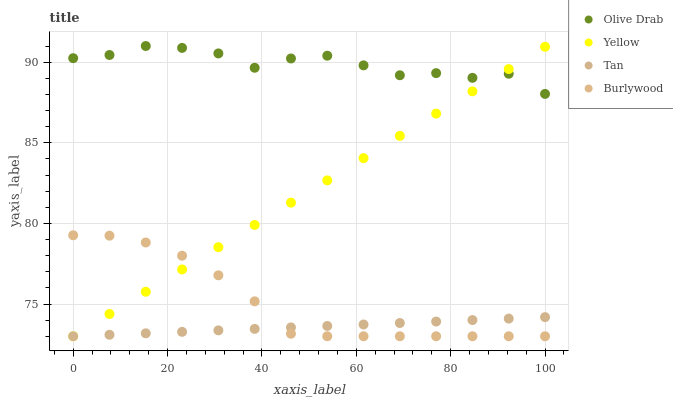Does Tan have the minimum area under the curve?
Answer yes or no. Yes. Does Olive Drab have the maximum area under the curve?
Answer yes or no. Yes. Does Yellow have the minimum area under the curve?
Answer yes or no. No. Does Yellow have the maximum area under the curve?
Answer yes or no. No. Is Tan the smoothest?
Answer yes or no. Yes. Is Olive Drab the roughest?
Answer yes or no. Yes. Is Yellow the smoothest?
Answer yes or no. No. Is Yellow the roughest?
Answer yes or no. No. Does Burlywood have the lowest value?
Answer yes or no. Yes. Does Olive Drab have the lowest value?
Answer yes or no. No. Does Olive Drab have the highest value?
Answer yes or no. Yes. Does Yellow have the highest value?
Answer yes or no. No. Is Burlywood less than Olive Drab?
Answer yes or no. Yes. Is Olive Drab greater than Burlywood?
Answer yes or no. Yes. Does Yellow intersect Olive Drab?
Answer yes or no. Yes. Is Yellow less than Olive Drab?
Answer yes or no. No. Is Yellow greater than Olive Drab?
Answer yes or no. No. Does Burlywood intersect Olive Drab?
Answer yes or no. No. 